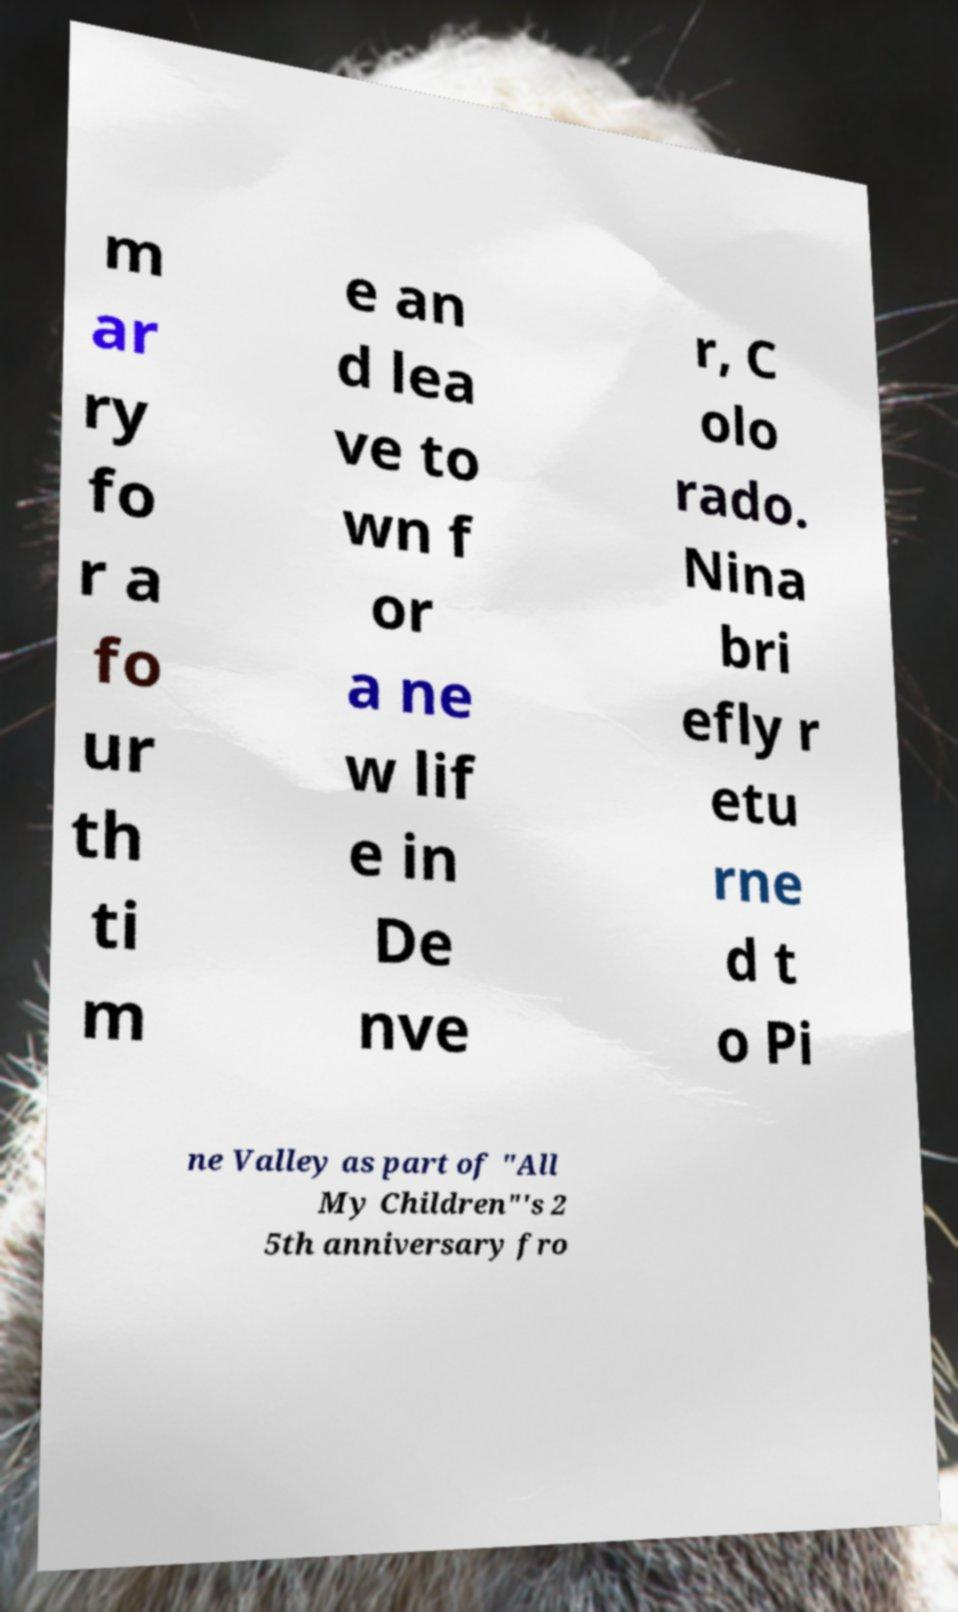Can you accurately transcribe the text from the provided image for me? m ar ry fo r a fo ur th ti m e an d lea ve to wn f or a ne w lif e in De nve r, C olo rado. Nina bri efly r etu rne d t o Pi ne Valley as part of "All My Children"'s 2 5th anniversary fro 